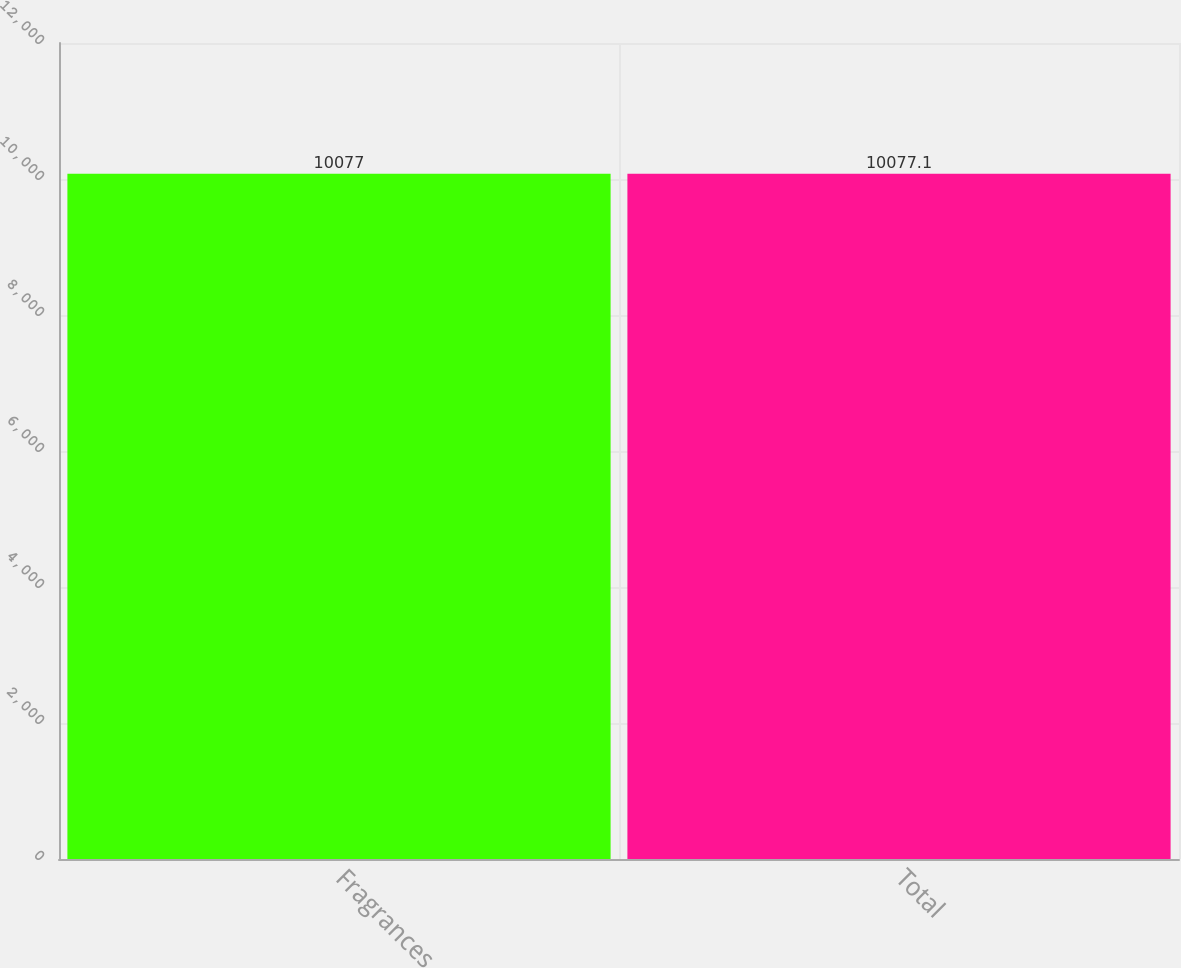<chart> <loc_0><loc_0><loc_500><loc_500><bar_chart><fcel>Fragrances<fcel>Total<nl><fcel>10077<fcel>10077.1<nl></chart> 